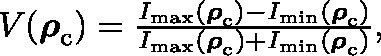Convert formula to latex. <formula><loc_0><loc_0><loc_500><loc_500>\begin{array} { r } { V ( \rho _ { c } ) = \frac { I _ { \max } ( \rho _ { c } ) - I _ { \min } ( \rho _ { c } ) } { I _ { \max } ( \rho _ { c } ) + I _ { \min } ( \rho _ { c } ) } , } \end{array}</formula> 